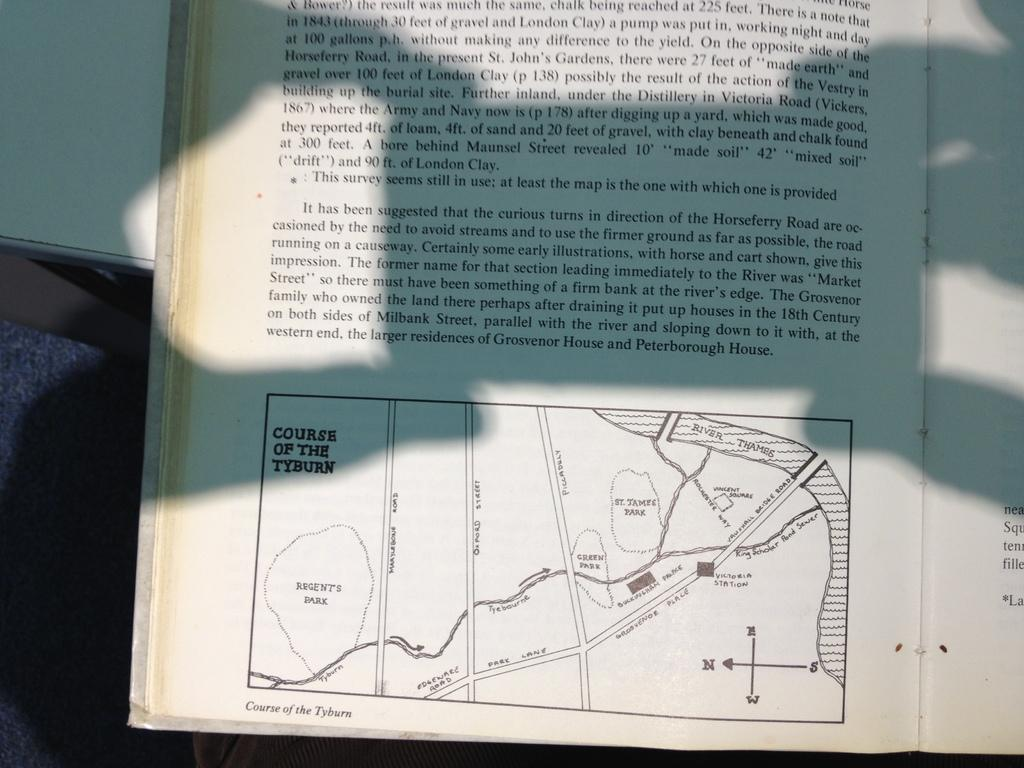<image>
Share a concise interpretation of the image provided. Book that includes a map about the courses of the Tyburn 